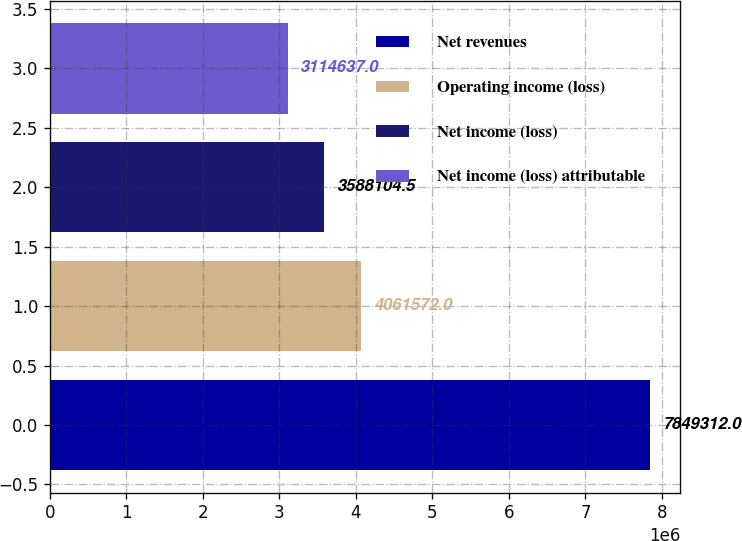<chart> <loc_0><loc_0><loc_500><loc_500><bar_chart><fcel>Net revenues<fcel>Operating income (loss)<fcel>Net income (loss)<fcel>Net income (loss) attributable<nl><fcel>7.84931e+06<fcel>4.06157e+06<fcel>3.5881e+06<fcel>3.11464e+06<nl></chart> 